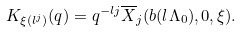Convert formula to latex. <formula><loc_0><loc_0><loc_500><loc_500>K _ { \xi ( l ^ { j } ) } ( q ) = q ^ { - l j } \overline { X } _ { j } ( b ( l \Lambda _ { 0 } ) , 0 , \xi ) .</formula> 